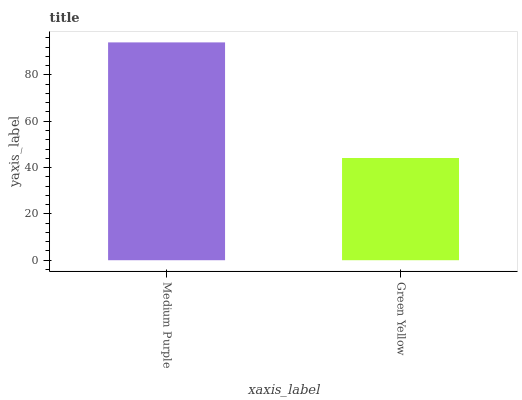Is Green Yellow the minimum?
Answer yes or no. Yes. Is Medium Purple the maximum?
Answer yes or no. Yes. Is Green Yellow the maximum?
Answer yes or no. No. Is Medium Purple greater than Green Yellow?
Answer yes or no. Yes. Is Green Yellow less than Medium Purple?
Answer yes or no. Yes. Is Green Yellow greater than Medium Purple?
Answer yes or no. No. Is Medium Purple less than Green Yellow?
Answer yes or no. No. Is Medium Purple the high median?
Answer yes or no. Yes. Is Green Yellow the low median?
Answer yes or no. Yes. Is Green Yellow the high median?
Answer yes or no. No. Is Medium Purple the low median?
Answer yes or no. No. 